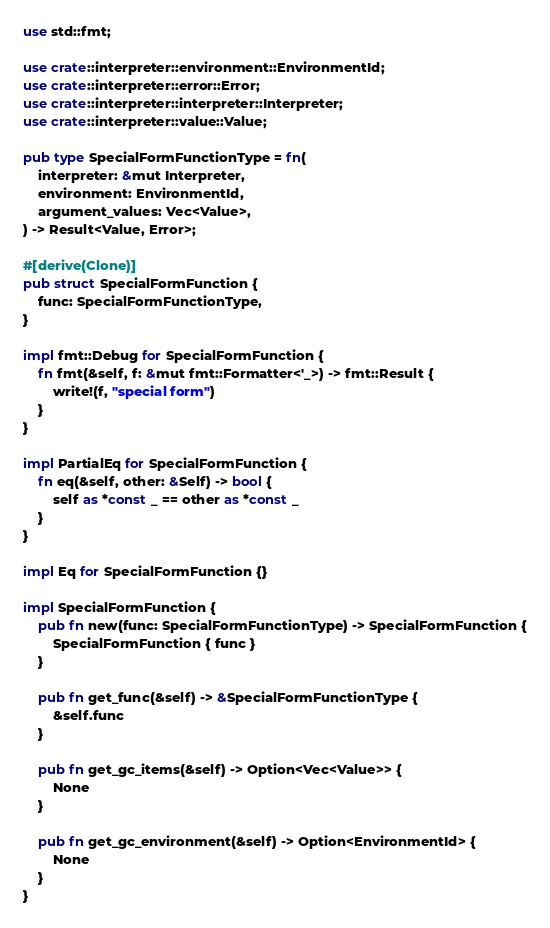Convert code to text. <code><loc_0><loc_0><loc_500><loc_500><_Rust_>use std::fmt;

use crate::interpreter::environment::EnvironmentId;
use crate::interpreter::error::Error;
use crate::interpreter::interpreter::Interpreter;
use crate::interpreter::value::Value;

pub type SpecialFormFunctionType = fn(
    interpreter: &mut Interpreter,
    environment: EnvironmentId,
    argument_values: Vec<Value>,
) -> Result<Value, Error>;

#[derive(Clone)]
pub struct SpecialFormFunction {
    func: SpecialFormFunctionType,
}

impl fmt::Debug for SpecialFormFunction {
    fn fmt(&self, f: &mut fmt::Formatter<'_>) -> fmt::Result {
        write!(f, "special form")
    }
}

impl PartialEq for SpecialFormFunction {
    fn eq(&self, other: &Self) -> bool {
        self as *const _ == other as *const _
    }
}

impl Eq for SpecialFormFunction {}

impl SpecialFormFunction {
    pub fn new(func: SpecialFormFunctionType) -> SpecialFormFunction {
        SpecialFormFunction { func }
    }

    pub fn get_func(&self) -> &SpecialFormFunctionType {
        &self.func
    }

    pub fn get_gc_items(&self) -> Option<Vec<Value>> {
        None
    }

    pub fn get_gc_environment(&self) -> Option<EnvironmentId> {
        None
    }
}
</code> 